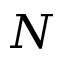<formula> <loc_0><loc_0><loc_500><loc_500>N</formula> 